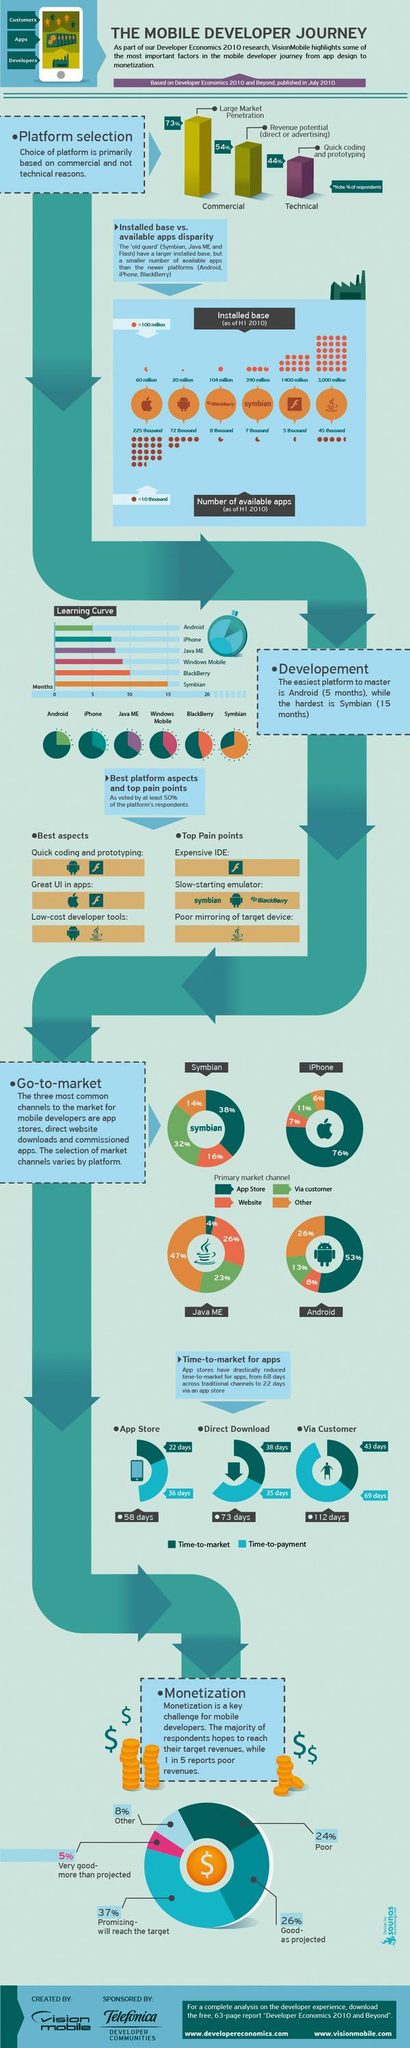Draw attention to some important aspects in this diagram. The time to payment for apps through the App Store is approximately 36 days. Android is the platform that supports low-cost developer tools. According to a recent study, the "App Store" is the primary market channel for 53% of Android developers. The high cost of the Adobe Integrated Development Environment (IDE) for Flash development is a common pain point for those working with the Flash platform. According to a survey of Java ME developers, 26% of them use the primary market channel of a website to release their applications. 